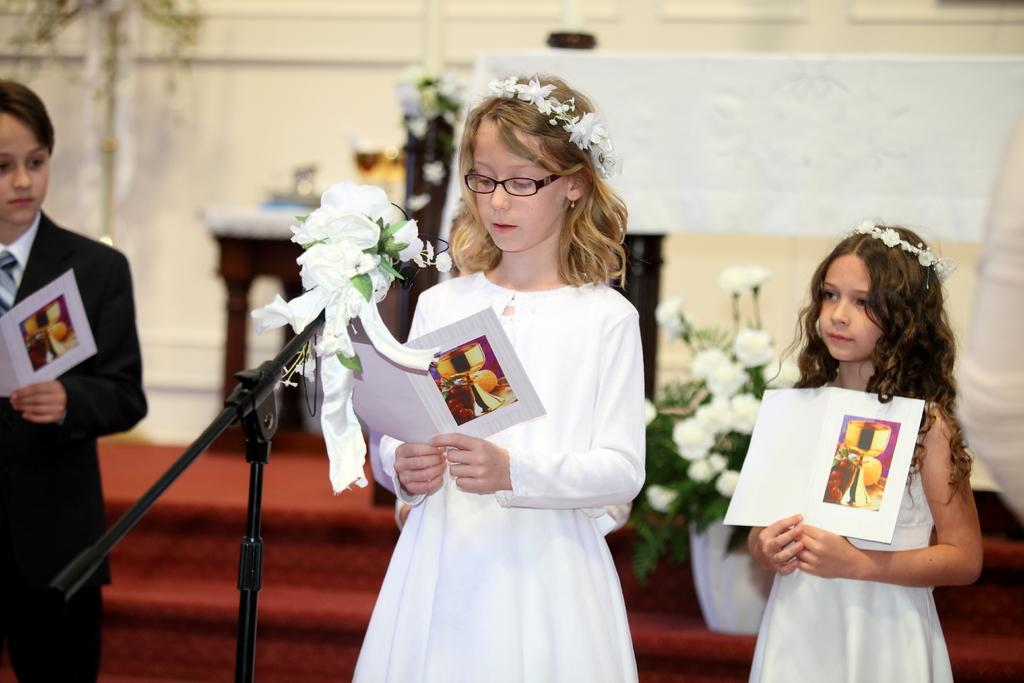What are the kids doing in the image? The kids are standing in the image, holding books. What object is present that is typically used for amplifying sound? There is a microphone in the image. What can be seen in the background of the image? There are white flowers and a wall in the background of the image. Can you tell me how many frogs are sitting on the wall in the image? There are no frogs present in the image; only kids, books, a microphone, white flowers, and a wall can be seen. What type of expert is giving a speech using the microphone in the image? There is no expert or speech present in the image; only the microphone is visible. 